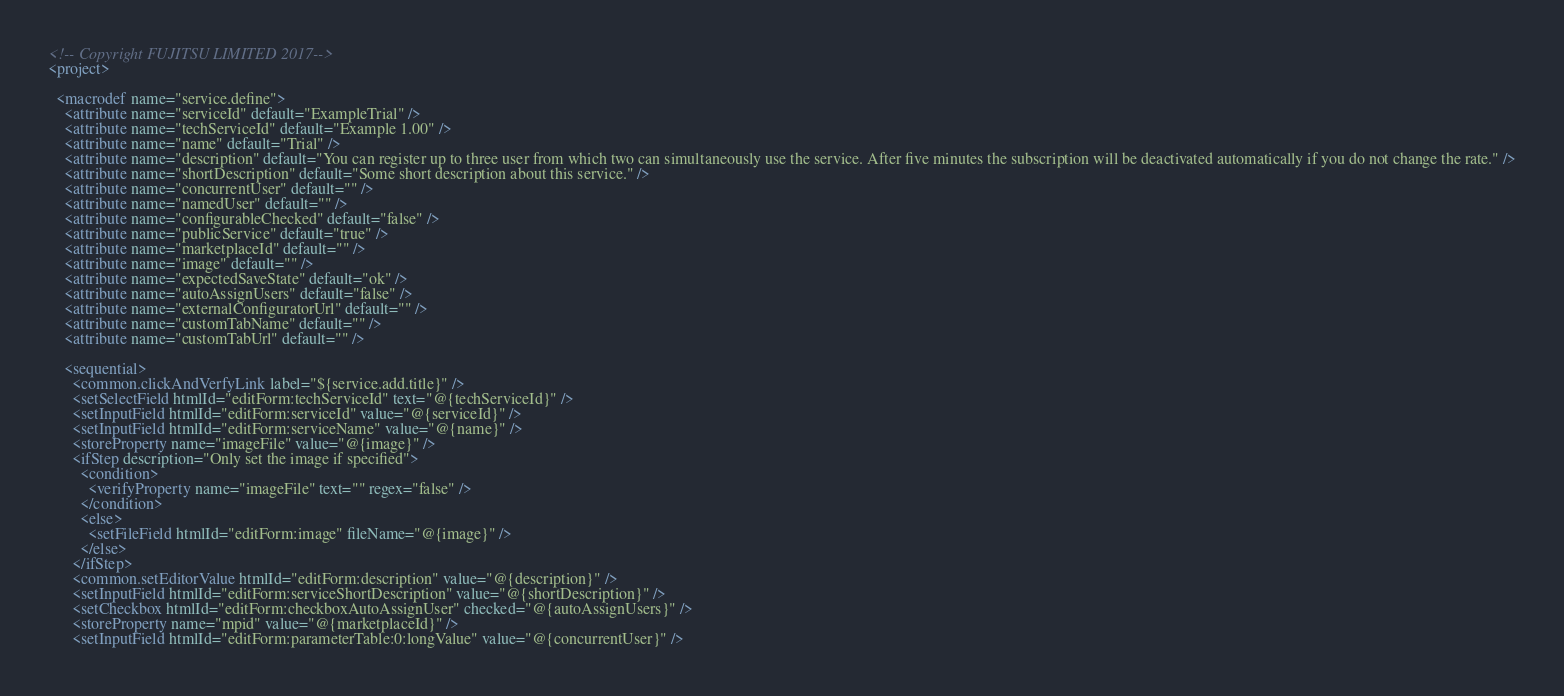<code> <loc_0><loc_0><loc_500><loc_500><_XML_><!-- Copyright FUJITSU LIMITED 2017-->
<project>

  <macrodef name="service.define">
    <attribute name="serviceId" default="ExampleTrial" />
    <attribute name="techServiceId" default="Example 1.00" />
    <attribute name="name" default="Trial" />
    <attribute name="description" default="You can register up to three user from which two can simultaneously use the service. After five minutes the subscription will be deactivated automatically if you do not change the rate." />
    <attribute name="shortDescription" default="Some short description about this service." />
    <attribute name="concurrentUser" default="" />
    <attribute name="namedUser" default="" />
    <attribute name="configurableChecked" default="false" />
    <attribute name="publicService" default="true" />
    <attribute name="marketplaceId" default="" />
    <attribute name="image" default="" />
    <attribute name="expectedSaveState" default="ok" />
    <attribute name="autoAssignUsers" default="false" />
    <attribute name="externalConfiguratorUrl" default="" />
    <attribute name="customTabName" default="" />
    <attribute name="customTabUrl" default="" />

    <sequential>
      <common.clickAndVerfyLink label="${service.add.title}" />
      <setSelectField htmlId="editForm:techServiceId" text="@{techServiceId}" />
      <setInputField htmlId="editForm:serviceId" value="@{serviceId}" />
      <setInputField htmlId="editForm:serviceName" value="@{name}" />
      <storeProperty name="imageFile" value="@{image}" />
      <ifStep description="Only set the image if specified">
        <condition>
          <verifyProperty name="imageFile" text="" regex="false" />
        </condition>
        <else>
          <setFileField htmlId="editForm:image" fileName="@{image}" />
        </else>
      </ifStep>
      <common.setEditorValue htmlId="editForm:description" value="@{description}" />
      <setInputField htmlId="editForm:serviceShortDescription" value="@{shortDescription}" />
      <setCheckbox htmlId="editForm:checkboxAutoAssignUser" checked="@{autoAssignUsers}" />
      <storeProperty name="mpid" value="@{marketplaceId}" />
      <setInputField htmlId="editForm:parameterTable:0:longValue" value="@{concurrentUser}" /></code> 